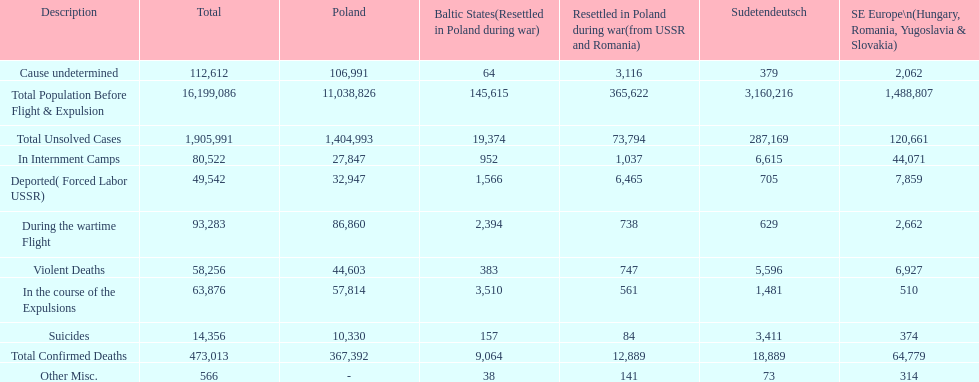What is the difference between suicides in poland and sudetendeutsch? 6919. 